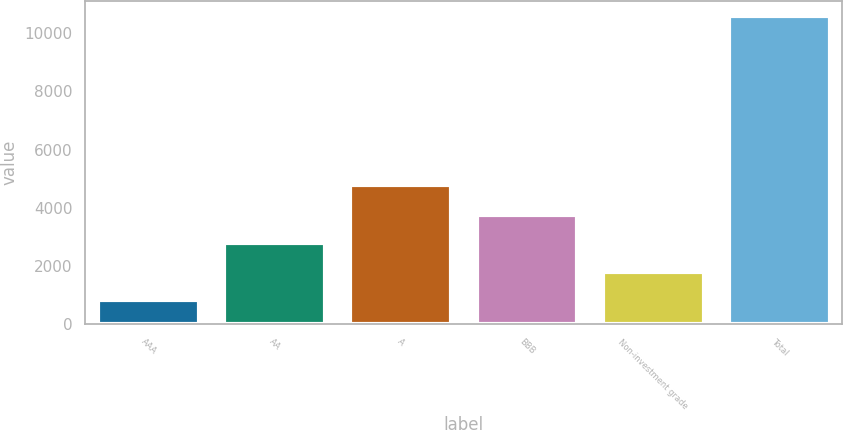Convert chart. <chart><loc_0><loc_0><loc_500><loc_500><bar_chart><fcel>AAA<fcel>AA<fcel>A<fcel>BBB<fcel>Non-investment grade<fcel>Total<nl><fcel>827<fcel>2778<fcel>4774<fcel>3753.5<fcel>1802.5<fcel>10582<nl></chart> 